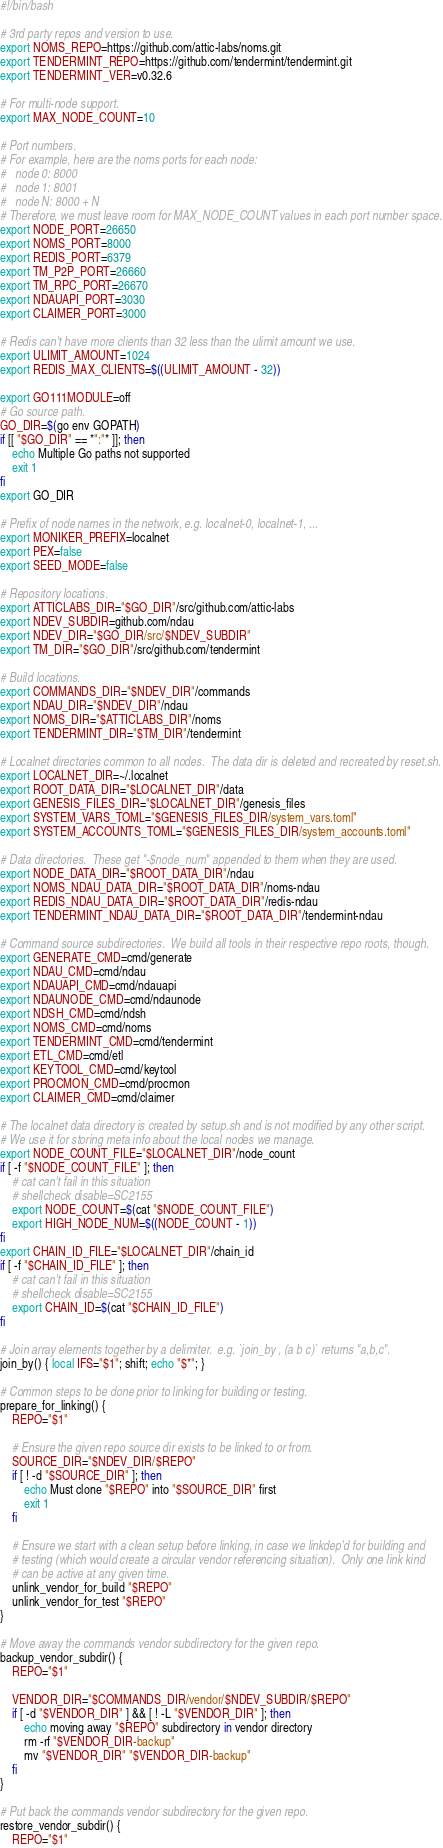<code> <loc_0><loc_0><loc_500><loc_500><_Bash_>#!/bin/bash

# 3rd party repos and version to use.
export NOMS_REPO=https://github.com/attic-labs/noms.git
export TENDERMINT_REPO=https://github.com/tendermint/tendermint.git
export TENDERMINT_VER=v0.32.6

# For multi-node support.
export MAX_NODE_COUNT=10

# Port numbers.
# For example, here are the noms ports for each node:
#   node 0: 8000
#   node 1: 8001
#   node N: 8000 + N
# Therefore, we must leave room for MAX_NODE_COUNT values in each port number space.
export NODE_PORT=26650
export NOMS_PORT=8000
export REDIS_PORT=6379
export TM_P2P_PORT=26660
export TM_RPC_PORT=26670
export NDAUAPI_PORT=3030
export CLAIMER_PORT=3000

# Redis can't have more clients than 32 less than the ulimit amount we use.
export ULIMIT_AMOUNT=1024
export REDIS_MAX_CLIENTS=$((ULIMIT_AMOUNT - 32))

export GO111MODULE=off
# Go source path.
GO_DIR=$(go env GOPATH)
if [[ "$GO_DIR" == *":"* ]]; then
    echo Multiple Go paths not supported
    exit 1
fi
export GO_DIR

# Prefix of node names in the network, e.g. localnet-0, localnet-1, ...
export MONIKER_PREFIX=localnet
export PEX=false
export SEED_MODE=false

# Repository locations.
export ATTICLABS_DIR="$GO_DIR"/src/github.com/attic-labs
export NDEV_SUBDIR=github.com/ndau
export NDEV_DIR="$GO_DIR/src/$NDEV_SUBDIR"
export TM_DIR="$GO_DIR"/src/github.com/tendermint

# Build locations.
export COMMANDS_DIR="$NDEV_DIR"/commands
export NDAU_DIR="$NDEV_DIR"/ndau
export NOMS_DIR="$ATTICLABS_DIR"/noms
export TENDERMINT_DIR="$TM_DIR"/tendermint

# Localnet directories common to all nodes.  The data dir is deleted and recreated by reset.sh.
export LOCALNET_DIR=~/.localnet
export ROOT_DATA_DIR="$LOCALNET_DIR"/data
export GENESIS_FILES_DIR="$LOCALNET_DIR"/genesis_files
export SYSTEM_VARS_TOML="$GENESIS_FILES_DIR/system_vars.toml"
export SYSTEM_ACCOUNTS_TOML="$GENESIS_FILES_DIR/system_accounts.toml"

# Data directories.  These get "-$node_num" appended to them when they are used.
export NODE_DATA_DIR="$ROOT_DATA_DIR"/ndau
export NOMS_NDAU_DATA_DIR="$ROOT_DATA_DIR"/noms-ndau
export REDIS_NDAU_DATA_DIR="$ROOT_DATA_DIR"/redis-ndau
export TENDERMINT_NDAU_DATA_DIR="$ROOT_DATA_DIR"/tendermint-ndau

# Command source subdirectories.  We build all tools in their respective repo roots, though.
export GENERATE_CMD=cmd/generate
export NDAU_CMD=cmd/ndau
export NDAUAPI_CMD=cmd/ndauapi
export NDAUNODE_CMD=cmd/ndaunode
export NDSH_CMD=cmd/ndsh
export NOMS_CMD=cmd/noms
export TENDERMINT_CMD=cmd/tendermint
export ETL_CMD=cmd/etl
export KEYTOOL_CMD=cmd/keytool
export PROCMON_CMD=cmd/procmon
export CLAIMER_CMD=cmd/claimer

# The localnet data directory is created by setup.sh and is not modified by any other script.
# We use it for storing meta info about the local nodes we manage.
export NODE_COUNT_FILE="$LOCALNET_DIR"/node_count
if [ -f "$NODE_COUNT_FILE" ]; then
    # cat can't fail in this situation
    # shellcheck disable=SC2155
    export NODE_COUNT=$(cat "$NODE_COUNT_FILE")
    export HIGH_NODE_NUM=$((NODE_COUNT - 1))
fi
export CHAIN_ID_FILE="$LOCALNET_DIR"/chain_id
if [ -f "$CHAIN_ID_FILE" ]; then
    # cat can't fail in this situation
    # shellcheck disable=SC2155
    export CHAIN_ID=$(cat "$CHAIN_ID_FILE")
fi

# Join array elements together by a delimiter.  e.g. `join_by , (a b c)` returns "a,b,c".
join_by() { local IFS="$1"; shift; echo "$*"; }

# Common steps to be done prior to linking for building or testing.
prepare_for_linking() {
    REPO="$1"

    # Ensure the given repo source dir exists to be linked to or from.
    SOURCE_DIR="$NDEV_DIR/$REPO"
    if [ ! -d "$SOURCE_DIR" ]; then
        echo Must clone "$REPO" into "$SOURCE_DIR" first
        exit 1
    fi

    # Ensure we start with a clean setup before linking, in case we linkdep'd for building and
    # testing (which would create a circular vendor referencing situation).  Only one link kind
    # can be active at any given time.
    unlink_vendor_for_build "$REPO"
    unlink_vendor_for_test "$REPO"
}

# Move away the commands vendor subdirectory for the given repo.
backup_vendor_subdir() {
    REPO="$1"

    VENDOR_DIR="$COMMANDS_DIR/vendor/$NDEV_SUBDIR/$REPO"
    if [ -d "$VENDOR_DIR" ] && [ ! -L "$VENDOR_DIR" ]; then
        echo moving away "$REPO" subdirectory in vendor directory
        rm -rf "$VENDOR_DIR-backup"
        mv "$VENDOR_DIR" "$VENDOR_DIR-backup"
    fi
}

# Put back the commands vendor subdirectory for the given repo.
restore_vendor_subdir() {
    REPO="$1"
</code> 